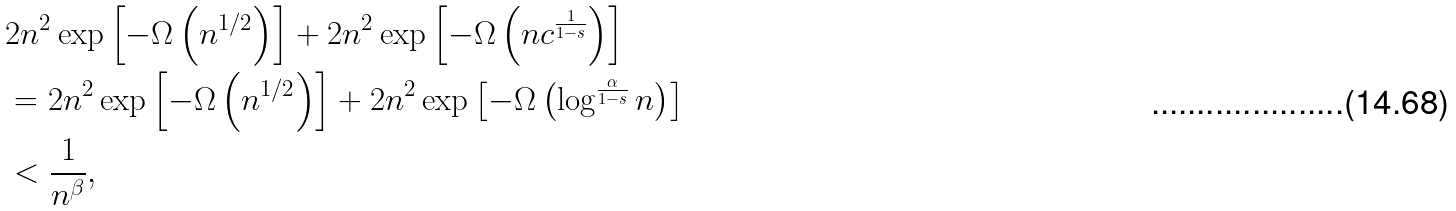Convert formula to latex. <formula><loc_0><loc_0><loc_500><loc_500>& 2 n ^ { 2 } \exp \left [ - \Omega \left ( n ^ { 1 / 2 } \right ) \right ] + 2 n ^ { 2 } \exp \left [ - \Omega \left ( n c ^ { \frac { 1 } { 1 - s } } \right ) \right ] \\ & = 2 n ^ { 2 } \exp \left [ - \Omega \left ( n ^ { 1 / 2 } \right ) \right ] + 2 n ^ { 2 } \exp \left [ - \Omega \left ( \log ^ { \frac { \alpha } { 1 - s } } n \right ) \right ] \\ & < \frac { 1 } { n ^ { \beta } } ,</formula> 